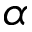<formula> <loc_0><loc_0><loc_500><loc_500>\alpha</formula> 